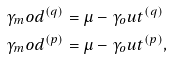Convert formula to latex. <formula><loc_0><loc_0><loc_500><loc_500>\gamma _ { m } o d ^ { ( q ) } & = \mu - \gamma _ { o } u t ^ { ( q ) } \\ \gamma _ { m } o d ^ { ( p ) } & = \mu - \gamma _ { o } u t ^ { ( p ) } ,</formula> 